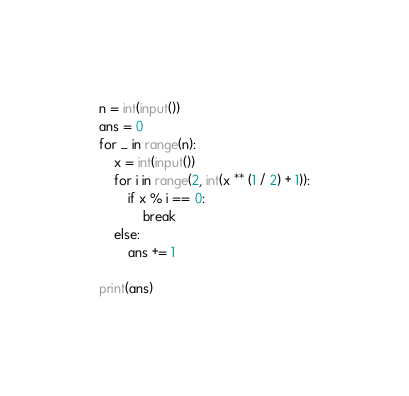<code> <loc_0><loc_0><loc_500><loc_500><_Python_>n = int(input())
ans = 0
for _ in range(n):
    x = int(input())
    for i in range(2, int(x ** (1 / 2) + 1)):
        if x % i == 0:
            break
    else:
        ans += 1

print(ans)

</code> 